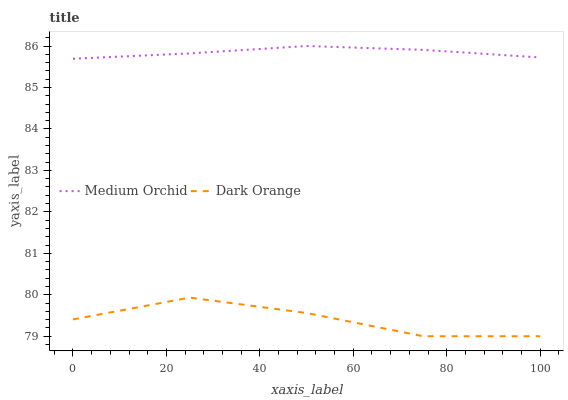Does Medium Orchid have the minimum area under the curve?
Answer yes or no. No. Is Medium Orchid the roughest?
Answer yes or no. No. Does Medium Orchid have the lowest value?
Answer yes or no. No. Is Dark Orange less than Medium Orchid?
Answer yes or no. Yes. Is Medium Orchid greater than Dark Orange?
Answer yes or no. Yes. Does Dark Orange intersect Medium Orchid?
Answer yes or no. No. 